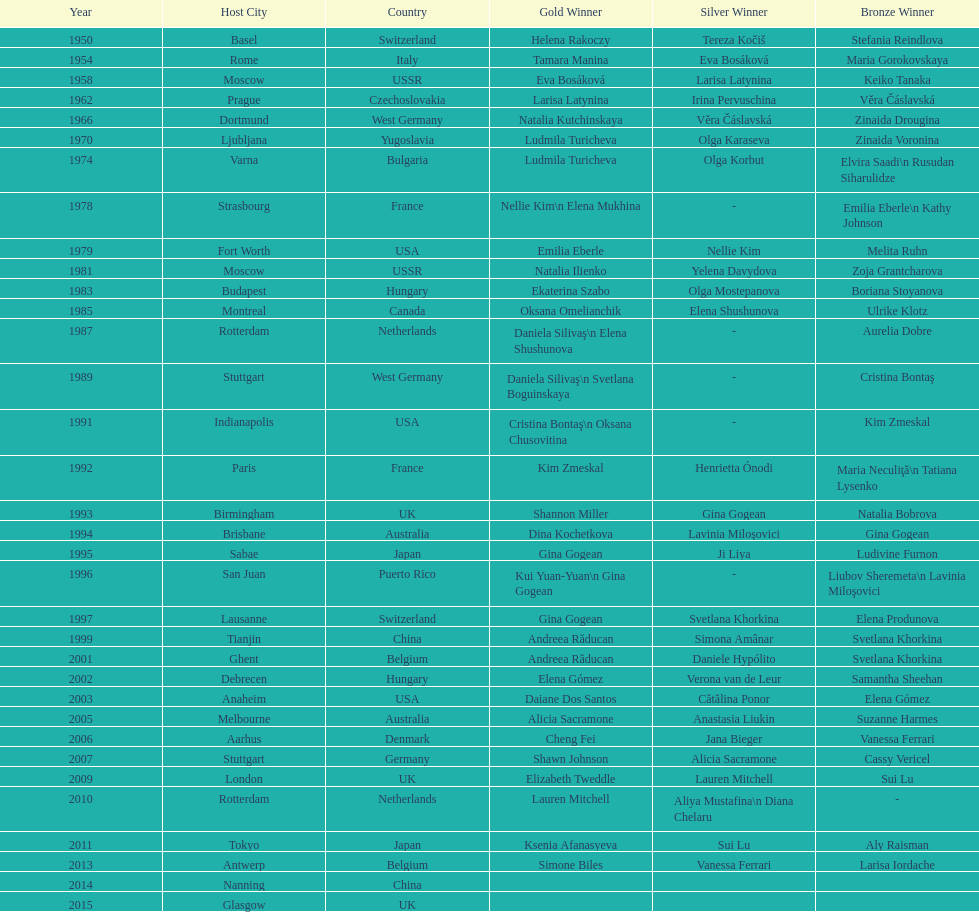What is the total number of russian gymnasts that have won silver. 8. Parse the table in full. {'header': ['Year', 'Host City', 'Country', 'Gold Winner', 'Silver Winner', 'Bronze Winner'], 'rows': [['1950', 'Basel', 'Switzerland', 'Helena Rakoczy', 'Tereza Kočiš', 'Stefania Reindlova'], ['1954', 'Rome', 'Italy', 'Tamara Manina', 'Eva Bosáková', 'Maria Gorokovskaya'], ['1958', 'Moscow', 'USSR', 'Eva Bosáková', 'Larisa Latynina', 'Keiko Tanaka'], ['1962', 'Prague', 'Czechoslovakia', 'Larisa Latynina', 'Irina Pervuschina', 'Věra Čáslavská'], ['1966', 'Dortmund', 'West Germany', 'Natalia Kutchinskaya', 'Věra Čáslavská', 'Zinaida Drougina'], ['1970', 'Ljubljana', 'Yugoslavia', 'Ludmila Turicheva', 'Olga Karaseva', 'Zinaida Voronina'], ['1974', 'Varna', 'Bulgaria', 'Ludmila Turicheva', 'Olga Korbut', 'Elvira Saadi\\n Rusudan Siharulidze'], ['1978', 'Strasbourg', 'France', 'Nellie Kim\\n Elena Mukhina', '-', 'Emilia Eberle\\n Kathy Johnson'], ['1979', 'Fort Worth', 'USA', 'Emilia Eberle', 'Nellie Kim', 'Melita Ruhn'], ['1981', 'Moscow', 'USSR', 'Natalia Ilienko', 'Yelena Davydova', 'Zoja Grantcharova'], ['1983', 'Budapest', 'Hungary', 'Ekaterina Szabo', 'Olga Mostepanova', 'Boriana Stoyanova'], ['1985', 'Montreal', 'Canada', 'Oksana Omelianchik', 'Elena Shushunova', 'Ulrike Klotz'], ['1987', 'Rotterdam', 'Netherlands', 'Daniela Silivaş\\n Elena Shushunova', '-', 'Aurelia Dobre'], ['1989', 'Stuttgart', 'West Germany', 'Daniela Silivaş\\n Svetlana Boguinskaya', '-', 'Cristina Bontaş'], ['1991', 'Indianapolis', 'USA', 'Cristina Bontaş\\n Oksana Chusovitina', '-', 'Kim Zmeskal'], ['1992', 'Paris', 'France', 'Kim Zmeskal', 'Henrietta Ónodi', 'Maria Neculiţă\\n Tatiana Lysenko'], ['1993', 'Birmingham', 'UK', 'Shannon Miller', 'Gina Gogean', 'Natalia Bobrova'], ['1994', 'Brisbane', 'Australia', 'Dina Kochetkova', 'Lavinia Miloşovici', 'Gina Gogean'], ['1995', 'Sabae', 'Japan', 'Gina Gogean', 'Ji Liya', 'Ludivine Furnon'], ['1996', 'San Juan', 'Puerto Rico', 'Kui Yuan-Yuan\\n Gina Gogean', '-', 'Liubov Sheremeta\\n Lavinia Miloşovici'], ['1997', 'Lausanne', 'Switzerland', 'Gina Gogean', 'Svetlana Khorkina', 'Elena Produnova'], ['1999', 'Tianjin', 'China', 'Andreea Răducan', 'Simona Amânar', 'Svetlana Khorkina'], ['2001', 'Ghent', 'Belgium', 'Andreea Răducan', 'Daniele Hypólito', 'Svetlana Khorkina'], ['2002', 'Debrecen', 'Hungary', 'Elena Gómez', 'Verona van de Leur', 'Samantha Sheehan'], ['2003', 'Anaheim', 'USA', 'Daiane Dos Santos', 'Cătălina Ponor', 'Elena Gómez'], ['2005', 'Melbourne', 'Australia', 'Alicia Sacramone', 'Anastasia Liukin', 'Suzanne Harmes'], ['2006', 'Aarhus', 'Denmark', 'Cheng Fei', 'Jana Bieger', 'Vanessa Ferrari'], ['2007', 'Stuttgart', 'Germany', 'Shawn Johnson', 'Alicia Sacramone', 'Cassy Vericel'], ['2009', 'London', 'UK', 'Elizabeth Tweddle', 'Lauren Mitchell', 'Sui Lu'], ['2010', 'Rotterdam', 'Netherlands', 'Lauren Mitchell', 'Aliya Mustafina\\n Diana Chelaru', '-'], ['2011', 'Tokyo', 'Japan', 'Ksenia Afanasyeva', 'Sui Lu', 'Aly Raisman'], ['2013', 'Antwerp', 'Belgium', 'Simone Biles', 'Vanessa Ferrari', 'Larisa Iordache'], ['2014', 'Nanning', 'China', '', '', ''], ['2015', 'Glasgow', 'UK', '', '', '']]} 